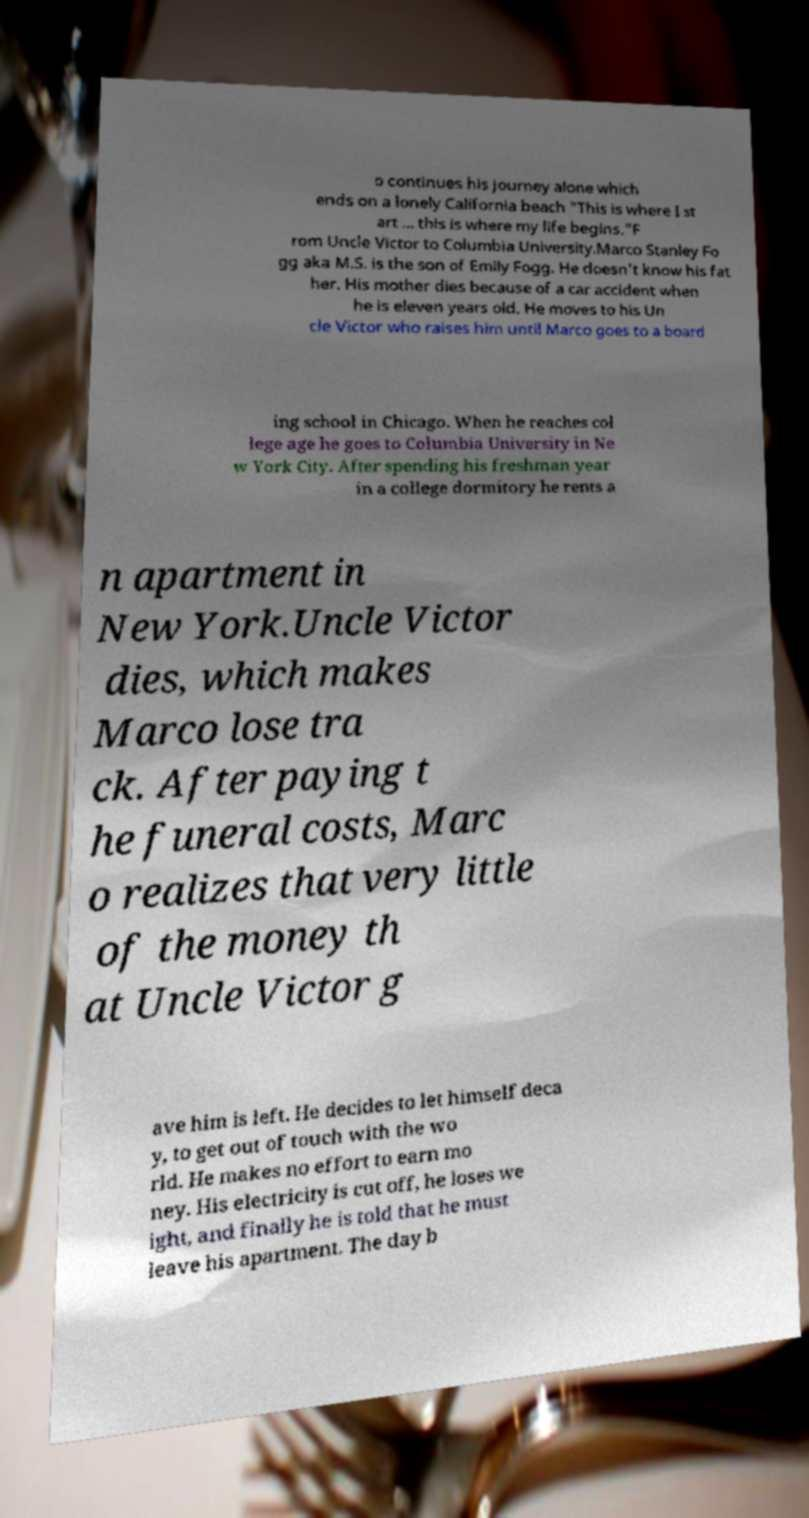I need the written content from this picture converted into text. Can you do that? o continues his journey alone which ends on a lonely California beach "This is where I st art ... this is where my life begins."F rom Uncle Victor to Columbia University.Marco Stanley Fo gg aka M.S. is the son of Emily Fogg. He doesn't know his fat her. His mother dies because of a car accident when he is eleven years old. He moves to his Un cle Victor who raises him until Marco goes to a board ing school in Chicago. When he reaches col lege age he goes to Columbia University in Ne w York City. After spending his freshman year in a college dormitory he rents a n apartment in New York.Uncle Victor dies, which makes Marco lose tra ck. After paying t he funeral costs, Marc o realizes that very little of the money th at Uncle Victor g ave him is left. He decides to let himself deca y, to get out of touch with the wo rld. He makes no effort to earn mo ney. His electricity is cut off, he loses we ight, and finally he is told that he must leave his apartment. The day b 